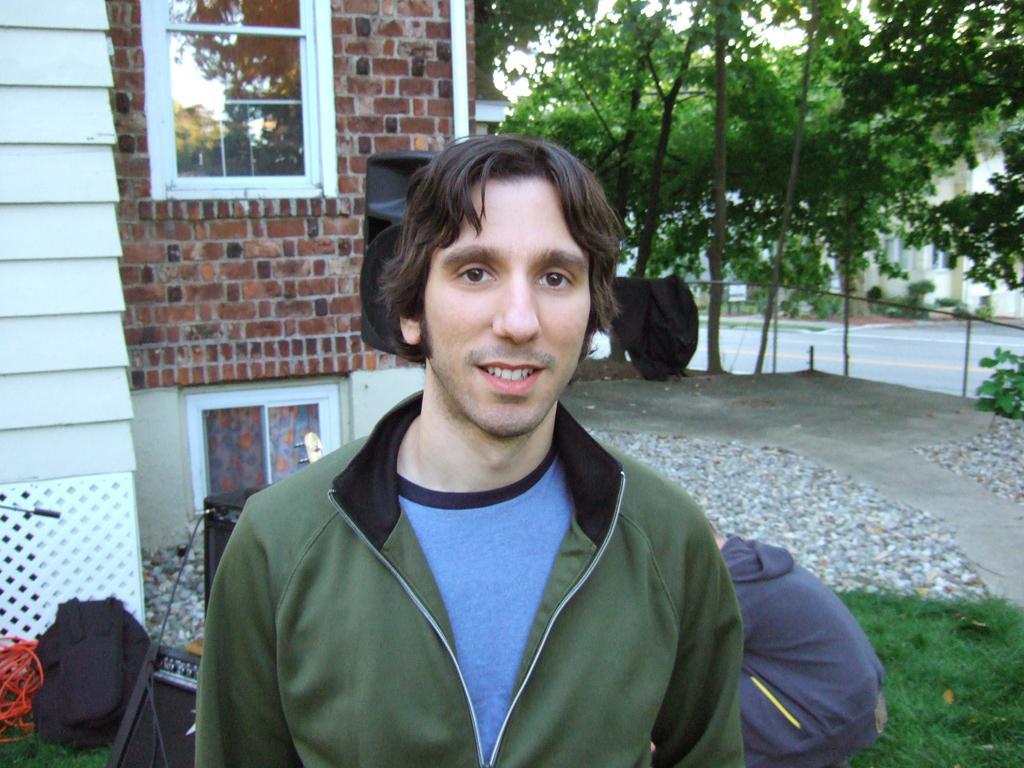How would you summarize this image in a sentence or two? In the image I can see a person wearing clothes. In the background, I can see the bags, wires, wall, window and groups of trees. I can see a person sitting. At the bottom of the image I can see the grass 